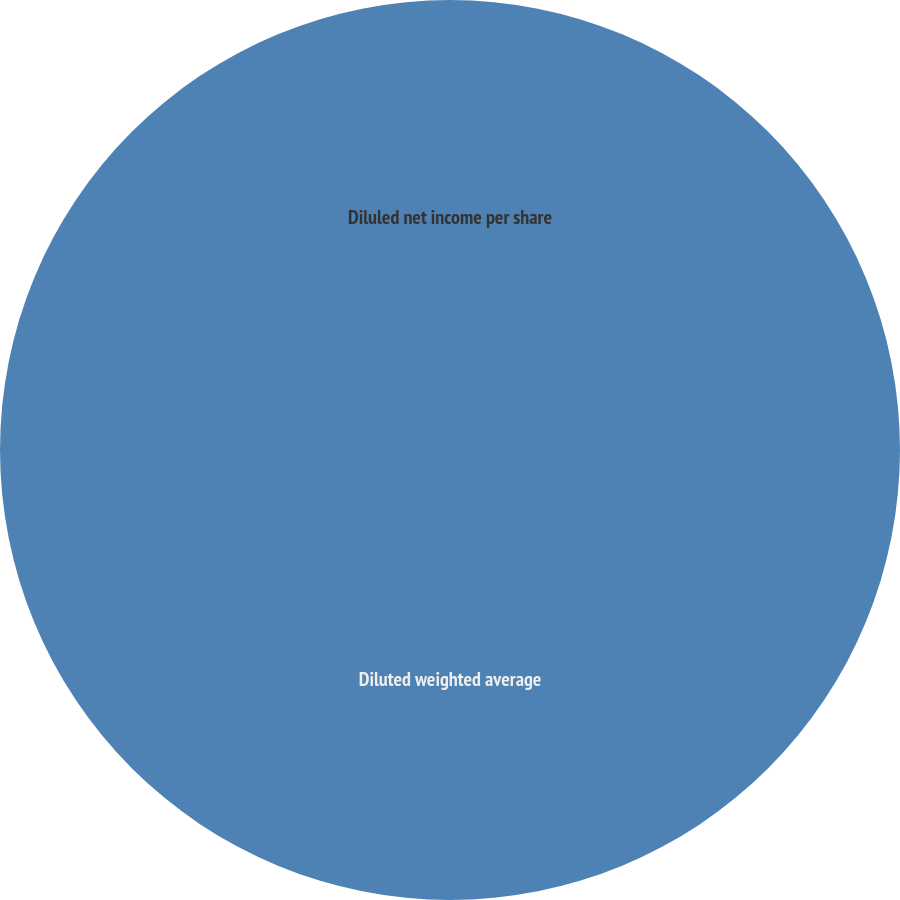Convert chart. <chart><loc_0><loc_0><loc_500><loc_500><pie_chart><fcel>Diluled net income per share<fcel>Diluted weighted average<nl><fcel>0.0%<fcel>100.0%<nl></chart> 